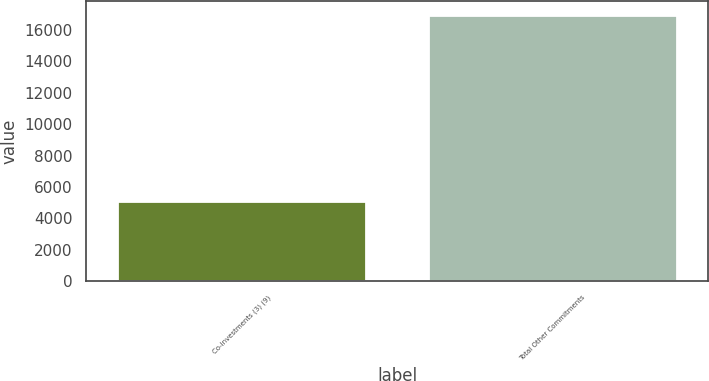<chart> <loc_0><loc_0><loc_500><loc_500><bar_chart><fcel>Co-investments (3) (9)<fcel>Total Other Commitments<nl><fcel>5127<fcel>16976<nl></chart> 